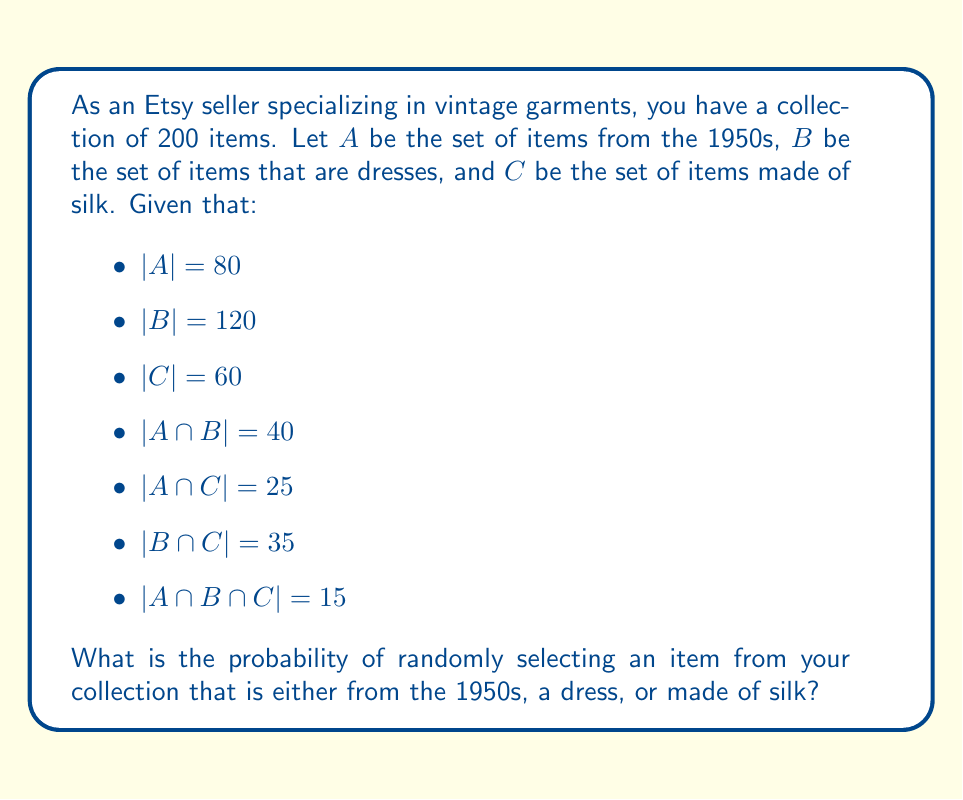Can you solve this math problem? To solve this problem, we need to use the inclusion-exclusion principle from set theory. The formula for the union of three sets is:

$$|A \cup B \cup C| = |A| + |B| + |C| - |A \cap B| - |A \cap C| - |B \cap C| + |A \cap B \cap C|$$

Let's substitute the given values:

$$|A \cup B \cup C| = 80 + 120 + 60 - 40 - 25 - 35 + 15 = 175$$

This means that there are 175 items that are either from the 1950s, dresses, or made of silk.

To find the probability, we divide the number of favorable outcomes by the total number of possible outcomes:

$$P(A \cup B \cup C) = \frac{|A \cup B \cup C|}{|\text{Total items}|} = \frac{175}{200} = \frac{7}{8} = 0.875$$
Answer: The probability of randomly selecting an item that is either from the 1950s, a dress, or made of silk is $\frac{7}{8}$ or 0.875 or 87.5%. 